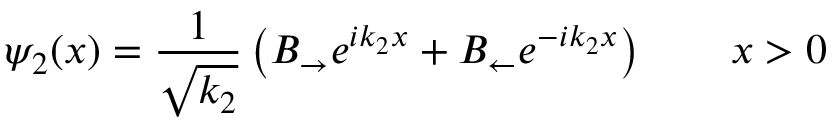Convert formula to latex. <formula><loc_0><loc_0><loc_500><loc_500>\psi _ { 2 } ( x ) = { \frac { 1 } { \sqrt { k _ { 2 } } } } \left ( B _ { \rightarrow } e ^ { i k _ { 2 } x } + B _ { \leftarrow } e ^ { - i k _ { 2 } x } \right ) \quad x > 0</formula> 